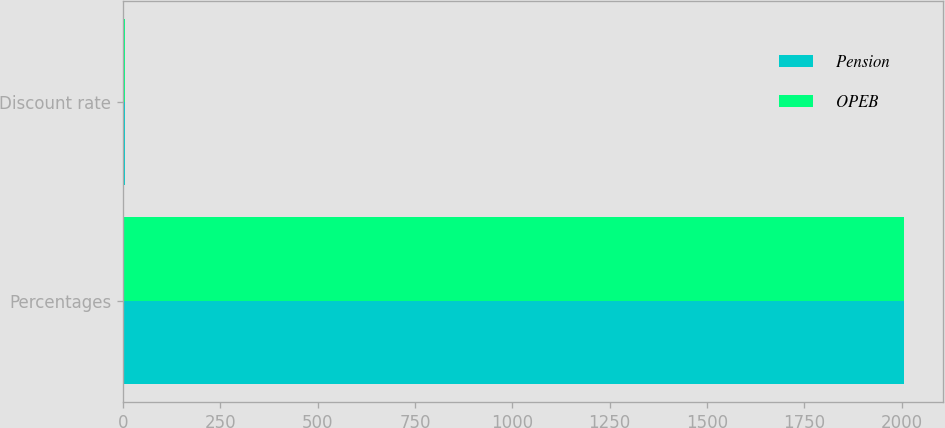<chart> <loc_0><loc_0><loc_500><loc_500><stacked_bar_chart><ecel><fcel>Percentages<fcel>Discount rate<nl><fcel>Pension<fcel>2006<fcel>5.75<nl><fcel>OPEB<fcel>2006<fcel>5.75<nl></chart> 